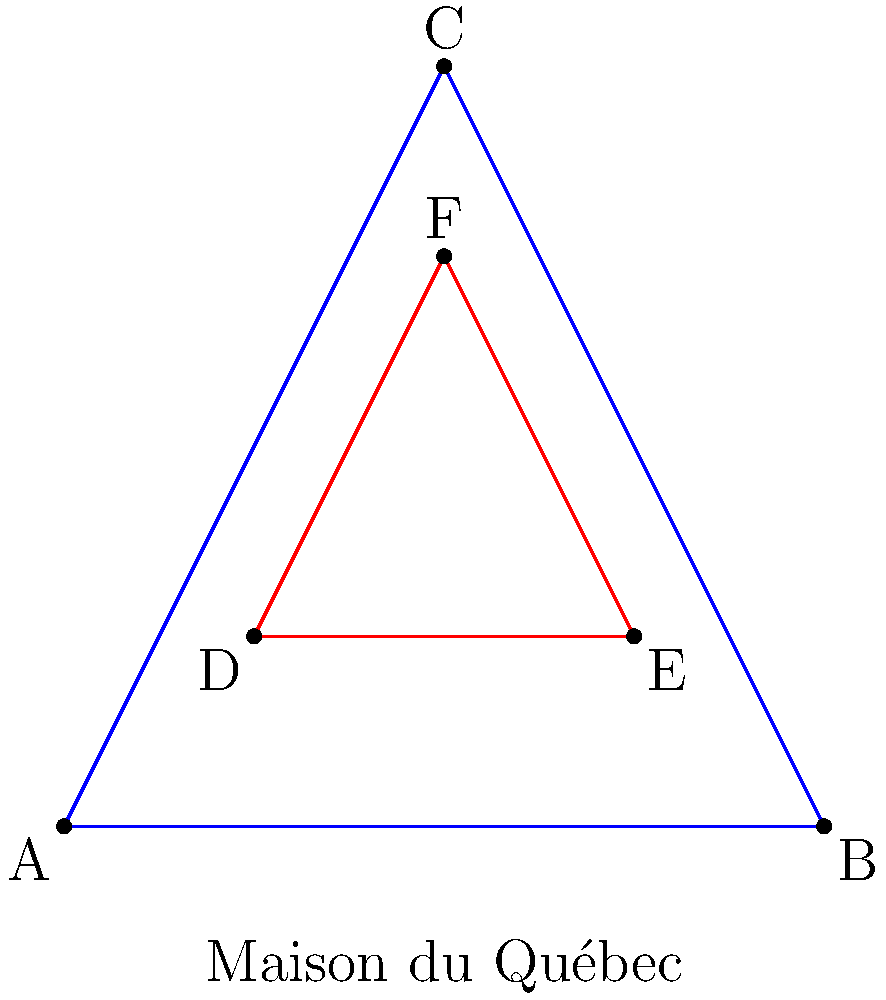In the architectural design of the Maison du Québec, inspired by Québécois literature and culture, two geometric shapes intersect as shown above. The blue triangle represents the main structure, while the red triangle represents an interior design element. If the area of the blue triangle is 8 square units, what is the area of the region where the two triangles overlap? To solve this problem, let's follow these steps:

1. Recognize that the blue triangle ABC is twice the size of the red triangle DEF.

2. Calculate the area of the red triangle DEF:
   Area of DEF = $\frac{1}{2}$ × Area of ABC
   Area of DEF = $\frac{1}{2}$ × 8 = 4 square units

3. Observe that the overlapping region is similar to both triangles, but is $\frac{1}{4}$ the size of the blue triangle ABC.

4. Calculate the area of the overlapping region:
   Overlapping area = $\frac{1}{4}$ × Area of ABC
   Overlapping area = $\frac{1}{4}$ × 8 = 2 square units

Therefore, the area of the region where the two triangles overlap is 2 square units.
Answer: 2 square units 